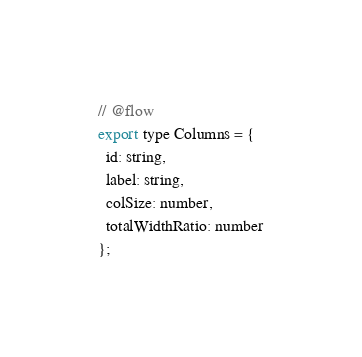Convert code to text. <code><loc_0><loc_0><loc_500><loc_500><_JavaScript_>// @flow
export type Columns = {
  id: string,
  label: string,
  colSize: number,
  totalWidthRatio: number
};
</code> 